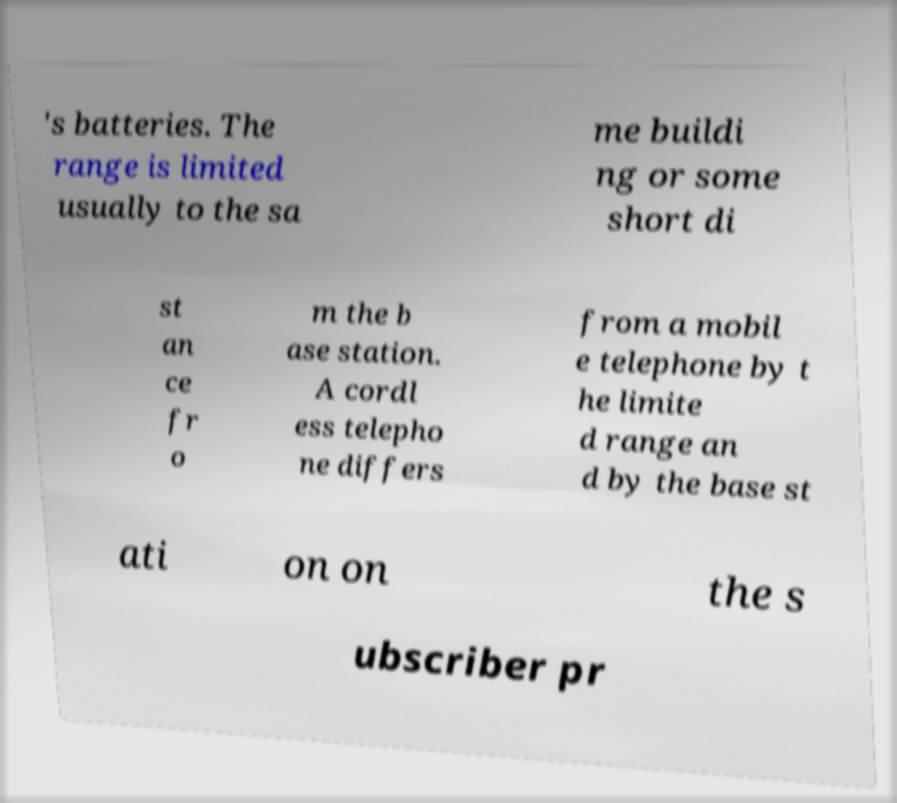What messages or text are displayed in this image? I need them in a readable, typed format. 's batteries. The range is limited usually to the sa me buildi ng or some short di st an ce fr o m the b ase station. A cordl ess telepho ne differs from a mobil e telephone by t he limite d range an d by the base st ati on on the s ubscriber pr 